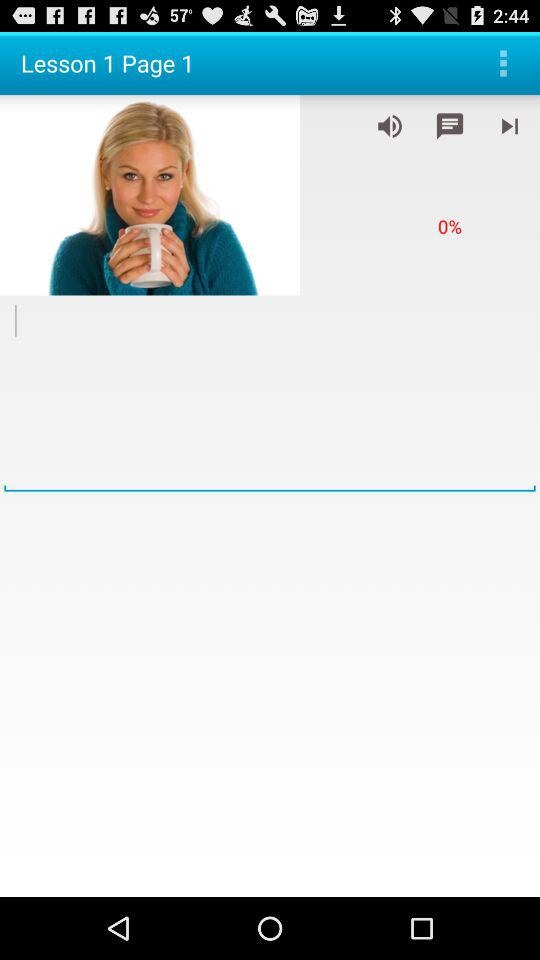Which page number are we currently on? You are on page number 1. 